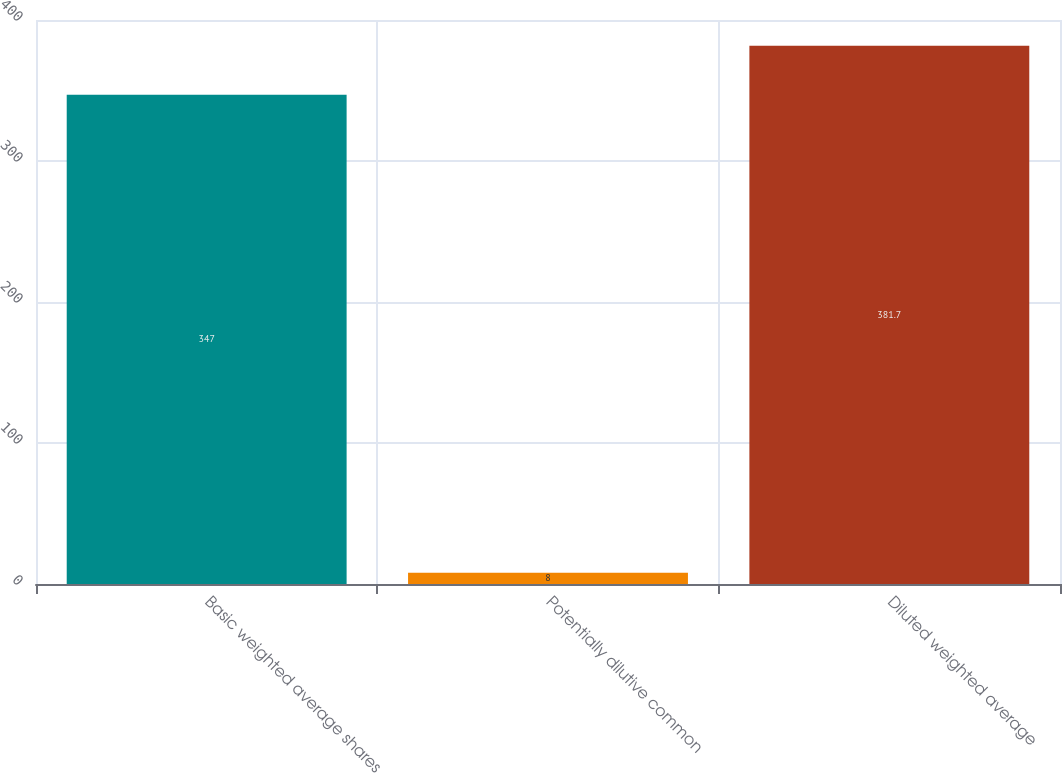Convert chart. <chart><loc_0><loc_0><loc_500><loc_500><bar_chart><fcel>Basic weighted average shares<fcel>Potentially dilutive common<fcel>Diluted weighted average<nl><fcel>347<fcel>8<fcel>381.7<nl></chart> 